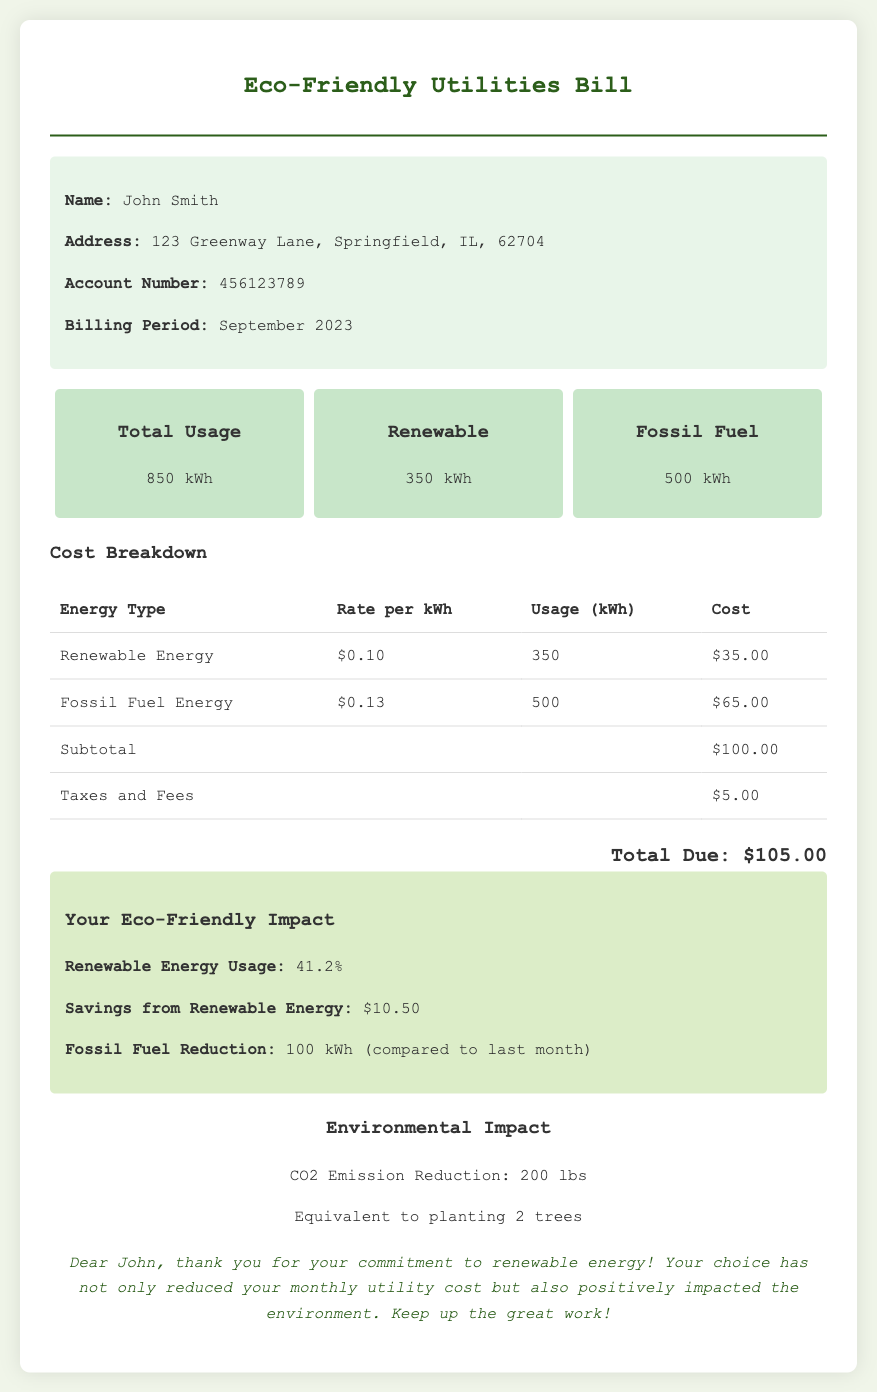What is the total usage of electricity? The total usage of electricity is stated in the usage summary section of the document as 850 kWh.
Answer: 850 kWh How much renewable energy was used? The amount of renewable energy usage is clearly indicated as 350 kWh in the usage summary section.
Answer: 350 kWh What is the rate per kWh for fossil fuel energy? The rate for fossil fuel energy is provided in the cost breakdown table, which lists it as $0.13 per kWh.
Answer: $0.13 What percentage of total usage is renewable energy? The renewable energy usage percentage is given in the savings info section as 41.2%.
Answer: 41.2% What is the total amount due? The total amount due is summarized at the end of the bill, which is stated as $105.00.
Answer: $105.00 How much savings is attributed to renewable energy? The savings from renewable energy usage is noted in the savings info section, listed as $10.50.
Answer: $10.50 What was the reduction in fossil fuel usage compared to last month? The document mentions a reduction of 100 kWh in fossil fuel usage in the savings info section.
Answer: 100 kWh What is the environmental impact in terms of CO2 emission reduction? The document states the CO2 emission reduction in the environmental impact section as 200 lbs.
Answer: 200 lbs How many trees is the CO2 emission reduction equivalent to? It is indicated in the environmental impact section that the reduction is equivalent to planting 2 trees.
Answer: 2 trees 